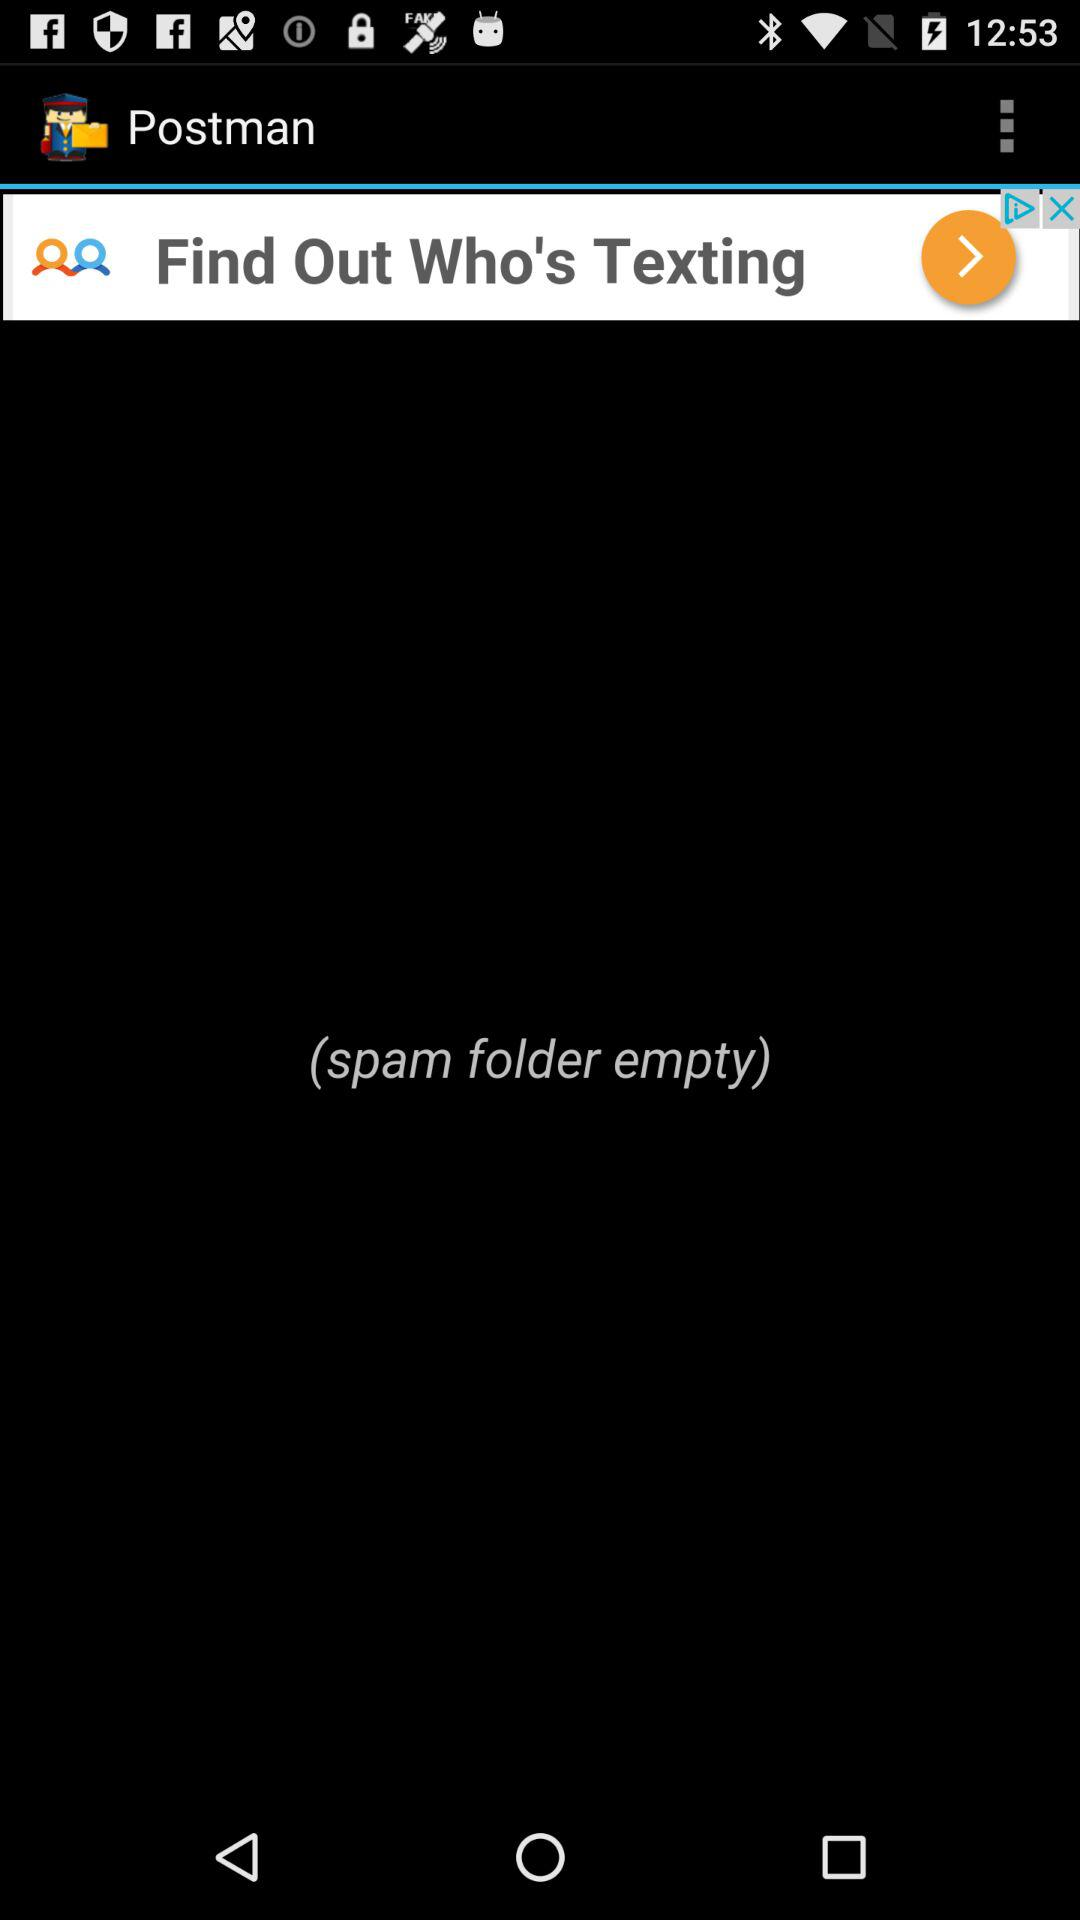How many items are in the "spam" folder? The "spam" folder is empty. 